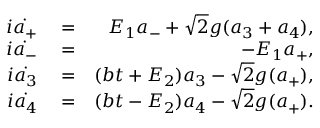Convert formula to latex. <formula><loc_0><loc_0><loc_500><loc_500>\begin{array} { r l r } { i \dot { a _ { + } } } & = } & { E _ { 1 } a _ { - } + \sqrt { 2 } g ( a _ { 3 } + a _ { 4 } ) , } \\ { i \dot { a _ { - } } } & = } & { - E _ { 1 } a _ { + } , } \\ { i \dot { a _ { 3 } } } & = } & { ( b t + E _ { 2 } ) a _ { 3 } - \sqrt { 2 } g ( a _ { + } ) , } \\ { i \dot { a _ { 4 } } } & = } & { ( b t - E _ { 2 } ) a _ { 4 } - \sqrt { 2 } g ( a _ { + } ) . } \end{array}</formula> 